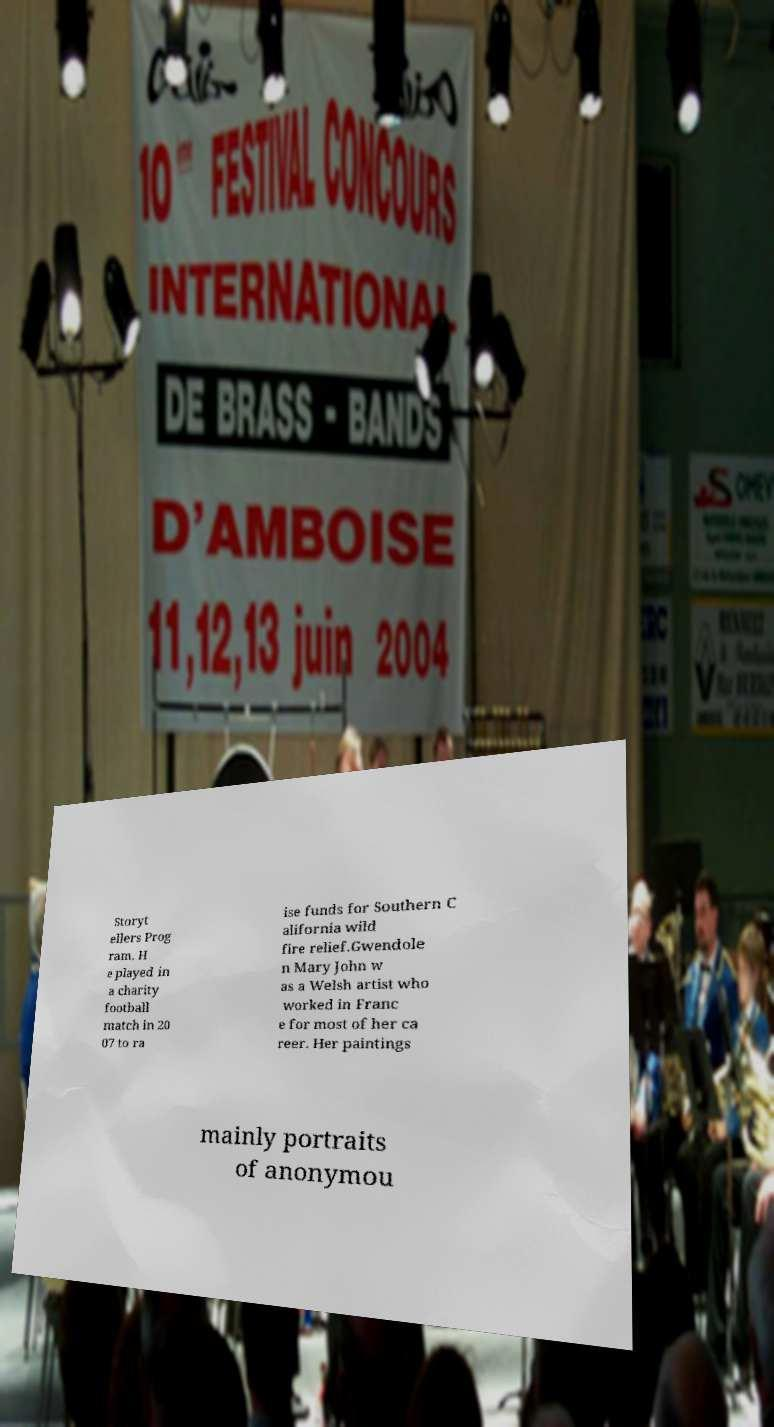Could you assist in decoding the text presented in this image and type it out clearly? Storyt ellers Prog ram. H e played in a charity football match in 20 07 to ra ise funds for Southern C alifornia wild fire relief.Gwendole n Mary John w as a Welsh artist who worked in Franc e for most of her ca reer. Her paintings mainly portraits of anonymou 